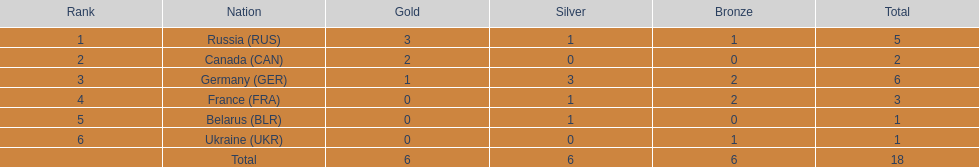How many silver medals have been awarded to belarus? 1. 